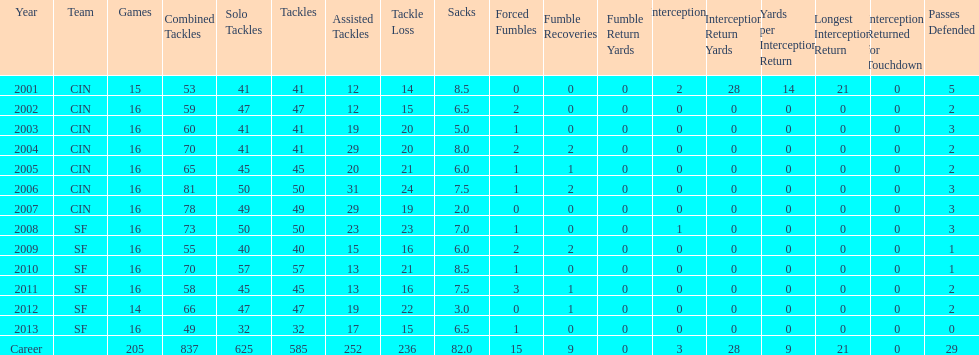What was the number of combined tackles in 2010? 70. 